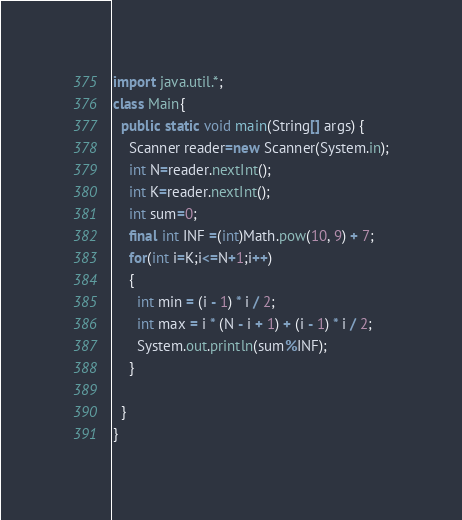<code> <loc_0><loc_0><loc_500><loc_500><_Java_>import java.util.*;
class Main{
  public static void main(String[] args) {
    Scanner reader=new Scanner(System.in);
    int N=reader.nextInt();
    int K=reader.nextInt();
    int sum=0;
    final int INF =(int)Math.pow(10, 9) + 7;
    for(int i=K;i<=N+1;i++)
    {
      int min = (i - 1) * i / 2;
      int max = i * (N - i + 1) + (i - 1) * i / 2;
      System.out.println(sum%INF);
    }

  }
}</code> 